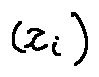<formula> <loc_0><loc_0><loc_500><loc_500>( z _ { i } )</formula> 